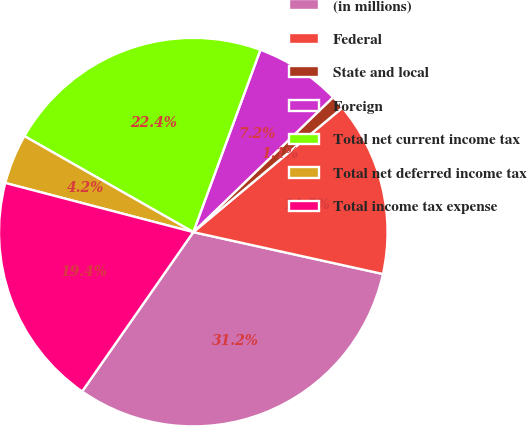Convert chart to OTSL. <chart><loc_0><loc_0><loc_500><loc_500><pie_chart><fcel>(in millions)<fcel>Federal<fcel>State and local<fcel>Foreign<fcel>Total net current income tax<fcel>Total net deferred income tax<fcel>Total income tax expense<nl><fcel>31.24%<fcel>14.53%<fcel>1.15%<fcel>7.17%<fcel>22.39%<fcel>4.16%<fcel>19.38%<nl></chart> 